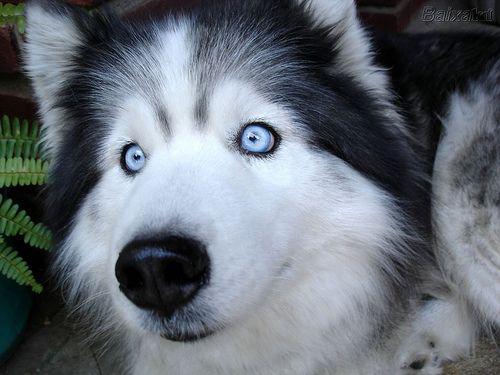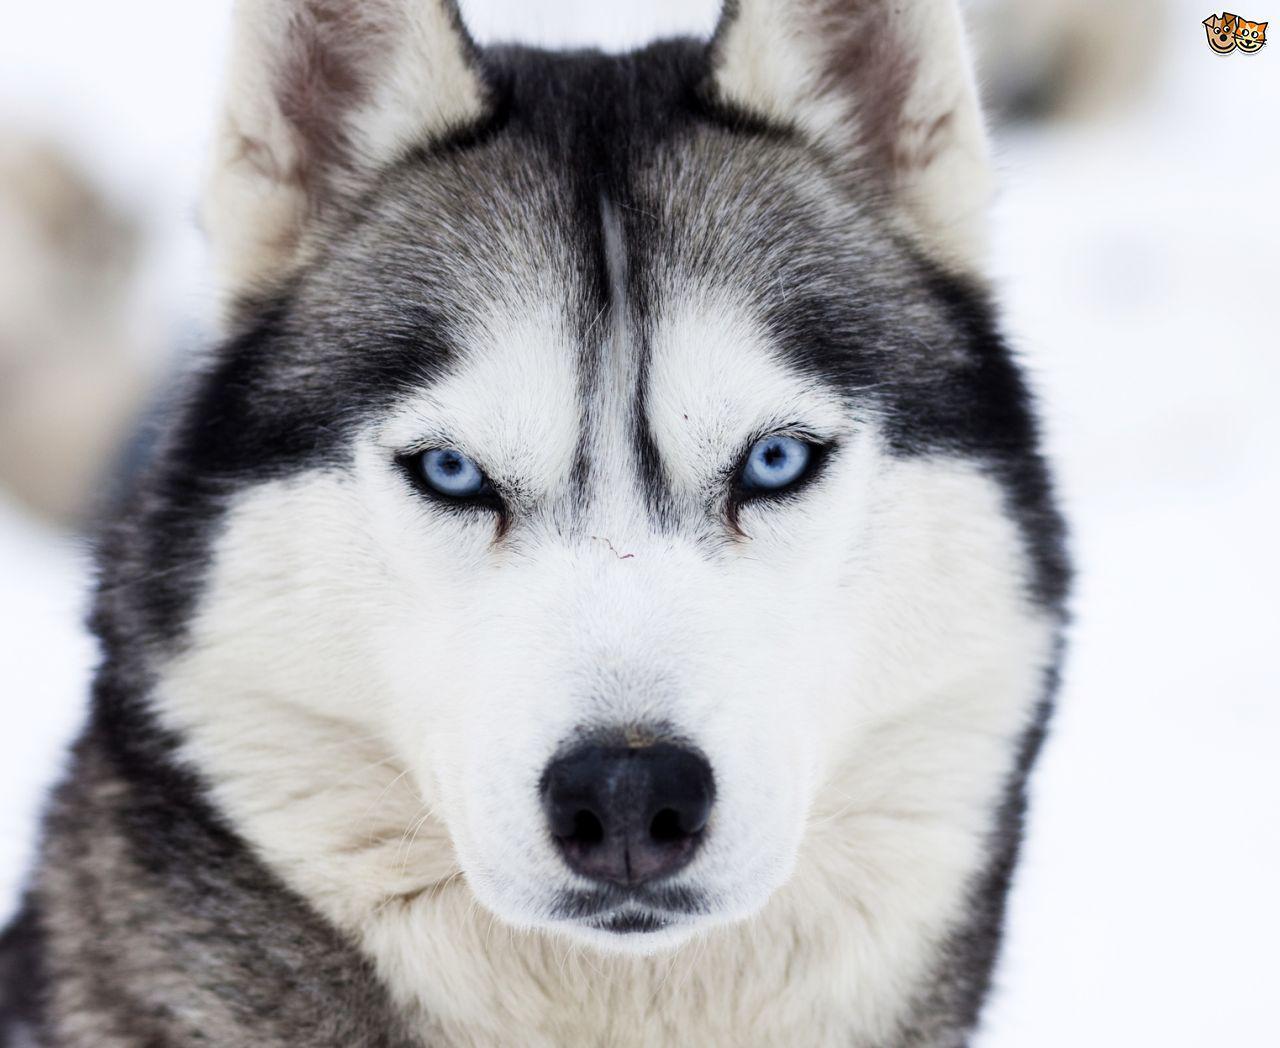The first image is the image on the left, the second image is the image on the right. Evaluate the accuracy of this statement regarding the images: "Each image contains one prominent camera-gazing husky dog with blue eyes and a closed mouth.". Is it true? Answer yes or no. Yes. The first image is the image on the left, the second image is the image on the right. Analyze the images presented: Is the assertion "There are two dogs with light colored eyes." valid? Answer yes or no. Yes. 